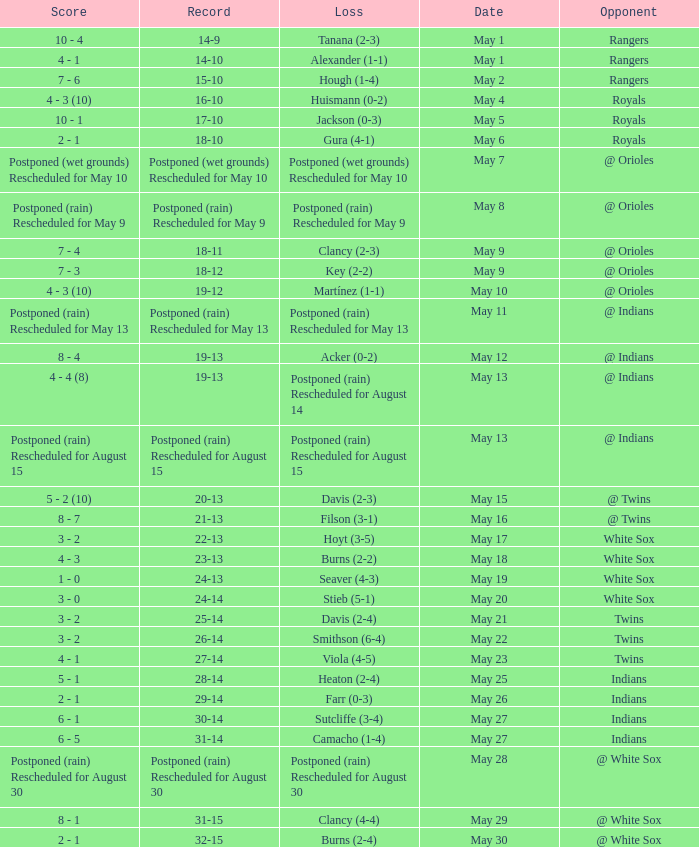What was the loss of the game when the record was 21-13? Filson (3-1). 